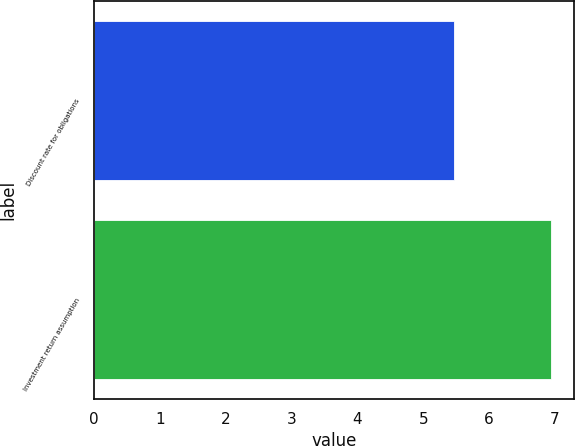Convert chart to OTSL. <chart><loc_0><loc_0><loc_500><loc_500><bar_chart><fcel>Discount rate for obligations<fcel>Investment return assumption<nl><fcel>5.46<fcel>6.94<nl></chart> 